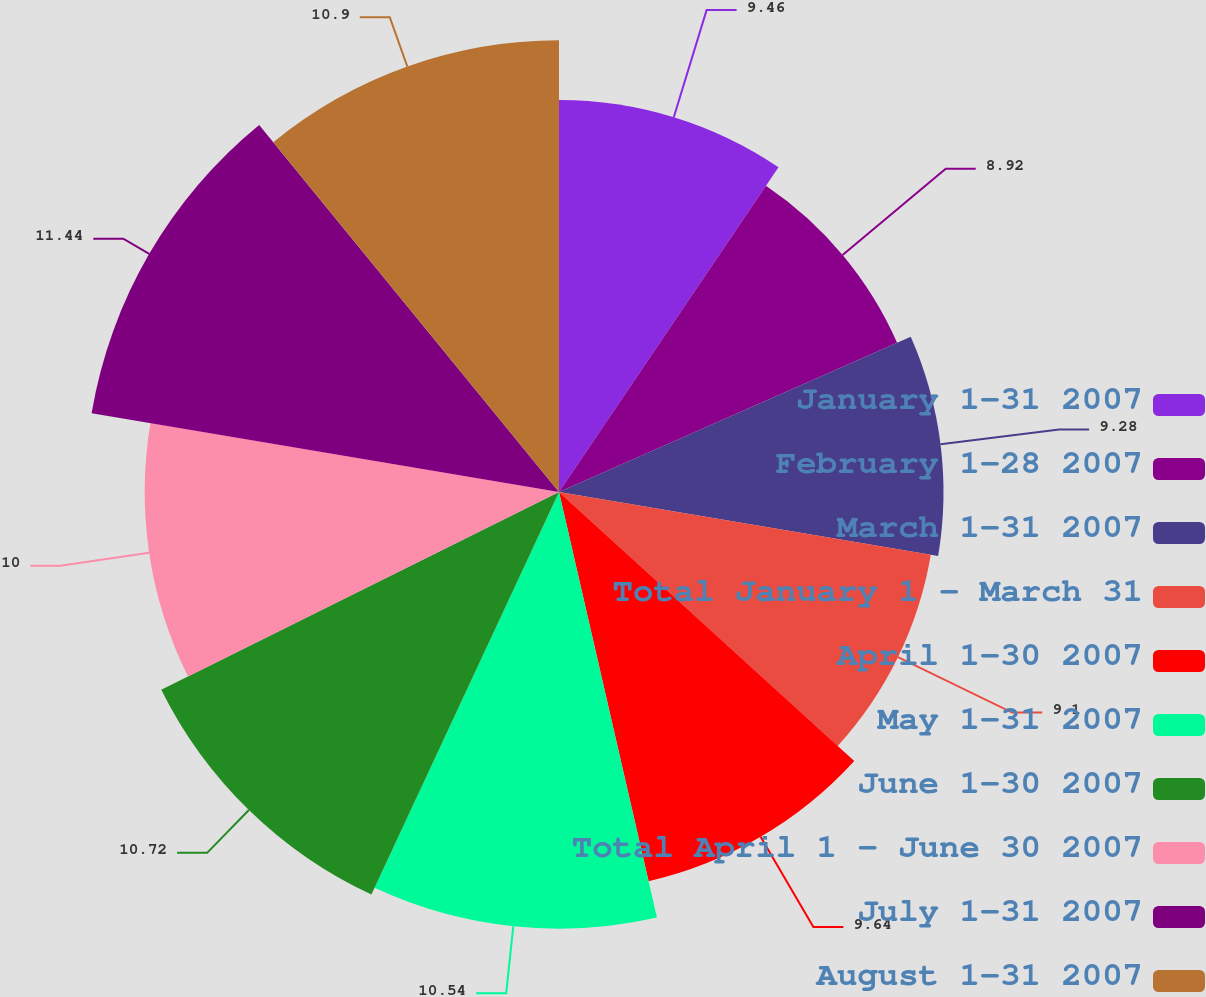Convert chart. <chart><loc_0><loc_0><loc_500><loc_500><pie_chart><fcel>January 1-31 2007<fcel>February 1-28 2007<fcel>March 1-31 2007<fcel>Total January 1 - March 31<fcel>April 1-30 2007<fcel>May 1-31 2007<fcel>June 1-30 2007<fcel>Total April 1 - June 30 2007<fcel>July 1-31 2007<fcel>August 1-31 2007<nl><fcel>9.46%<fcel>8.92%<fcel>9.28%<fcel>9.1%<fcel>9.64%<fcel>10.54%<fcel>10.72%<fcel>10.0%<fcel>11.44%<fcel>10.9%<nl></chart> 